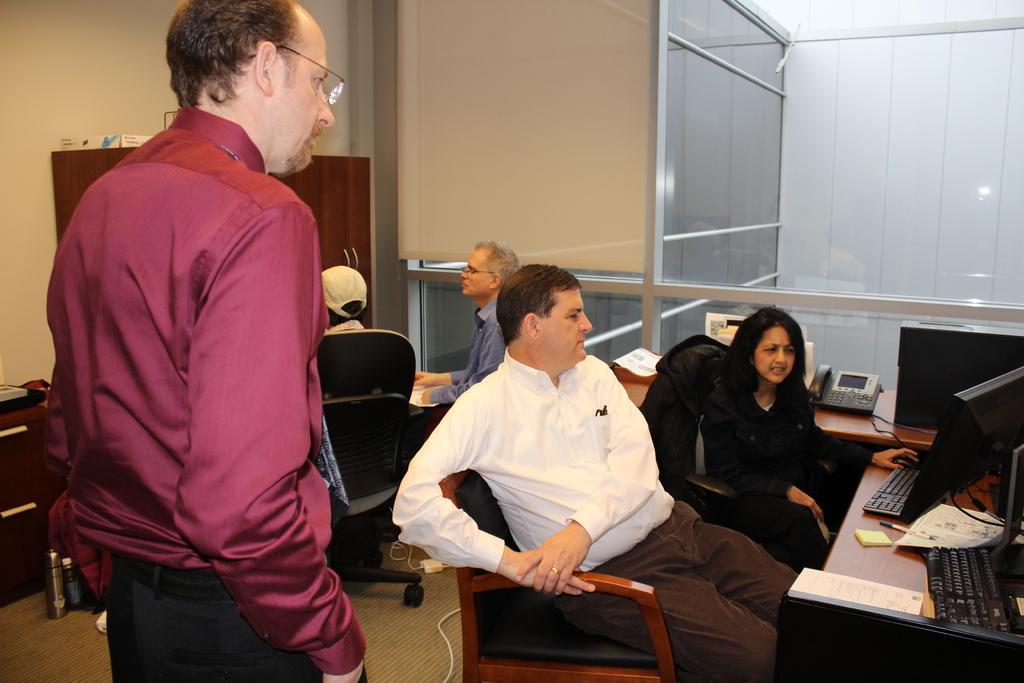Please provide a concise description of this image. In this picture we can see some persons are sitting on the chairs. This is the table. On the table there is a keyboard, monitor, CPU, phone, and a book. Here we can see a person who is standing on the floor. And on the background there is a wall. And this is the cupboard. 